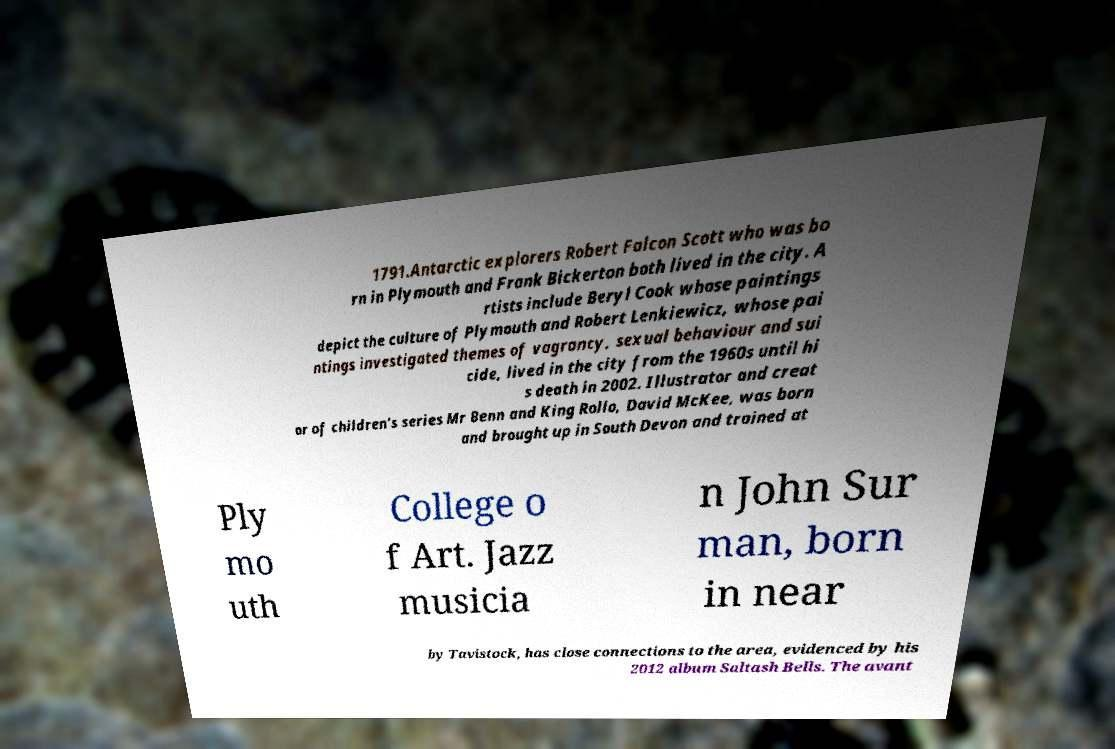What messages or text are displayed in this image? I need them in a readable, typed format. 1791.Antarctic explorers Robert Falcon Scott who was bo rn in Plymouth and Frank Bickerton both lived in the city. A rtists include Beryl Cook whose paintings depict the culture of Plymouth and Robert Lenkiewicz, whose pai ntings investigated themes of vagrancy, sexual behaviour and sui cide, lived in the city from the 1960s until hi s death in 2002. Illustrator and creat or of children's series Mr Benn and King Rollo, David McKee, was born and brought up in South Devon and trained at Ply mo uth College o f Art. Jazz musicia n John Sur man, born in near by Tavistock, has close connections to the area, evidenced by his 2012 album Saltash Bells. The avant 